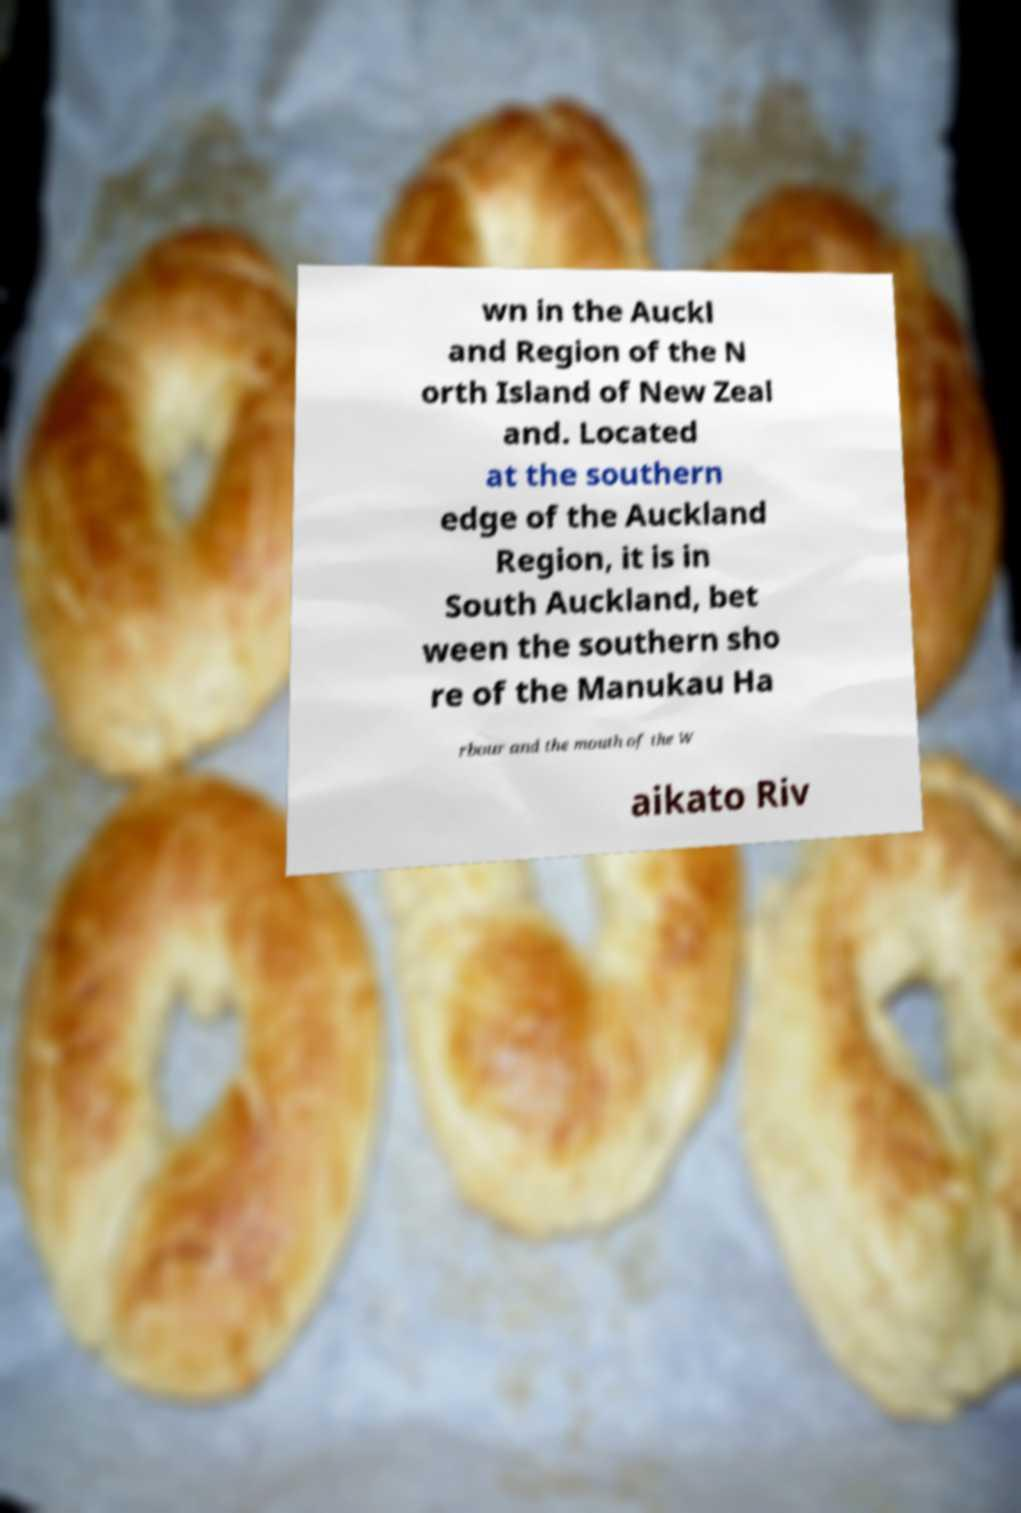I need the written content from this picture converted into text. Can you do that? wn in the Auckl and Region of the N orth Island of New Zeal and. Located at the southern edge of the Auckland Region, it is in South Auckland, bet ween the southern sho re of the Manukau Ha rbour and the mouth of the W aikato Riv 